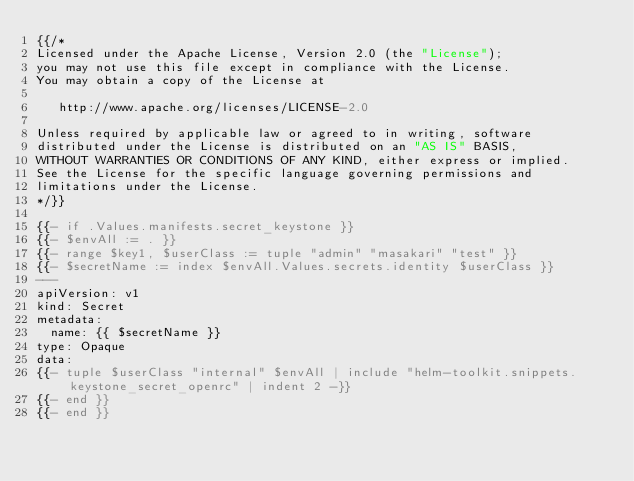<code> <loc_0><loc_0><loc_500><loc_500><_YAML_>{{/*
Licensed under the Apache License, Version 2.0 (the "License");
you may not use this file except in compliance with the License.
You may obtain a copy of the License at

   http://www.apache.org/licenses/LICENSE-2.0

Unless required by applicable law or agreed to in writing, software
distributed under the License is distributed on an "AS IS" BASIS,
WITHOUT WARRANTIES OR CONDITIONS OF ANY KIND, either express or implied.
See the License for the specific language governing permissions and
limitations under the License.
*/}}

{{- if .Values.manifests.secret_keystone }}
{{- $envAll := . }}
{{- range $key1, $userClass := tuple "admin" "masakari" "test" }}
{{- $secretName := index $envAll.Values.secrets.identity $userClass }}
---
apiVersion: v1
kind: Secret
metadata:
  name: {{ $secretName }}
type: Opaque
data:
{{- tuple $userClass "internal" $envAll | include "helm-toolkit.snippets.keystone_secret_openrc" | indent 2 -}}
{{- end }}
{{- end }}
</code> 